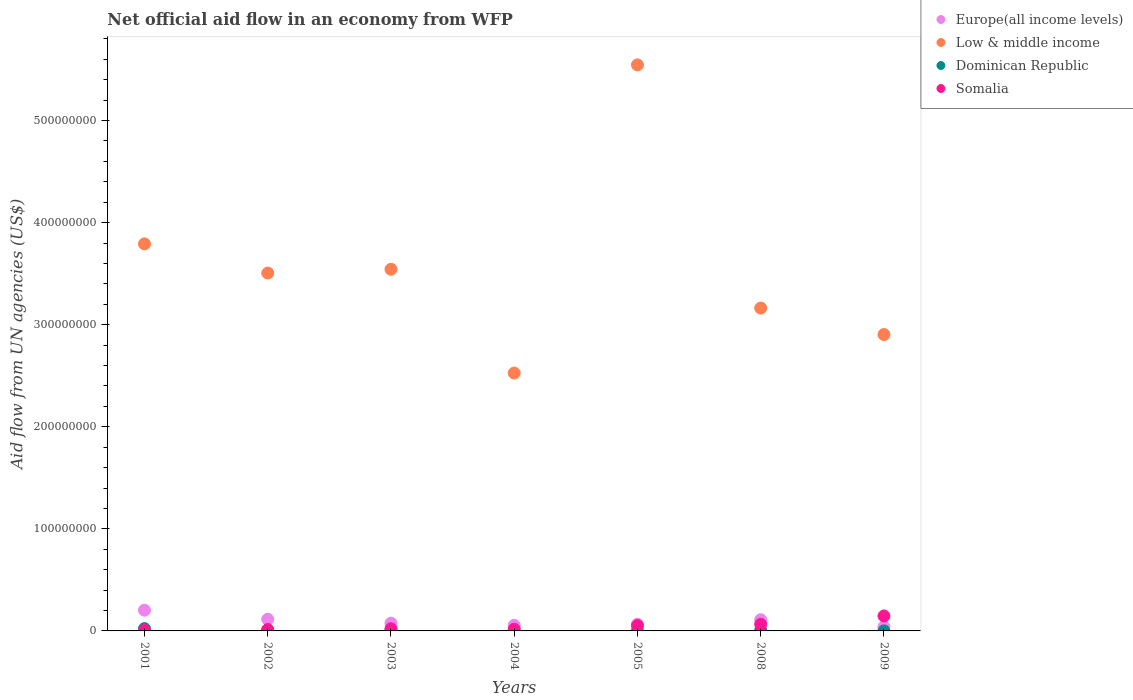How many different coloured dotlines are there?
Make the answer very short. 4. Is the number of dotlines equal to the number of legend labels?
Provide a succinct answer. Yes. What is the net official aid flow in Dominican Republic in 2009?
Provide a short and direct response. 3.00e+04. Across all years, what is the maximum net official aid flow in Low & middle income?
Provide a succinct answer. 5.55e+08. Across all years, what is the minimum net official aid flow in Somalia?
Offer a very short reply. 9.90e+05. What is the total net official aid flow in Dominican Republic in the graph?
Give a very brief answer. 3.99e+06. What is the difference between the net official aid flow in Somalia in 2003 and that in 2009?
Offer a very short reply. -1.25e+07. What is the difference between the net official aid flow in Europe(all income levels) in 2004 and the net official aid flow in Somalia in 2009?
Keep it short and to the point. -9.22e+06. What is the average net official aid flow in Low & middle income per year?
Your response must be concise. 3.57e+08. In the year 2005, what is the difference between the net official aid flow in Dominican Republic and net official aid flow in Europe(all income levels)?
Your response must be concise. -6.54e+06. What is the ratio of the net official aid flow in Dominican Republic in 2001 to that in 2003?
Make the answer very short. 5.14. Is the net official aid flow in Low & middle income in 2001 less than that in 2004?
Ensure brevity in your answer.  No. Is the difference between the net official aid flow in Dominican Republic in 2003 and 2005 greater than the difference between the net official aid flow in Europe(all income levels) in 2003 and 2005?
Your answer should be very brief. No. What is the difference between the highest and the second highest net official aid flow in Somalia?
Offer a terse response. 8.11e+06. What is the difference between the highest and the lowest net official aid flow in Europe(all income levels)?
Offer a terse response. 1.62e+07. Is the sum of the net official aid flow in Dominican Republic in 2001 and 2005 greater than the maximum net official aid flow in Low & middle income across all years?
Keep it short and to the point. No. Is it the case that in every year, the sum of the net official aid flow in Europe(all income levels) and net official aid flow in Dominican Republic  is greater than the net official aid flow in Low & middle income?
Provide a succinct answer. No. Does the net official aid flow in Dominican Republic monotonically increase over the years?
Make the answer very short. No. Is the net official aid flow in Europe(all income levels) strictly less than the net official aid flow in Low & middle income over the years?
Provide a short and direct response. Yes. How many years are there in the graph?
Make the answer very short. 7. What is the difference between two consecutive major ticks on the Y-axis?
Your answer should be very brief. 1.00e+08. Does the graph contain any zero values?
Give a very brief answer. No. Does the graph contain grids?
Offer a terse response. No. How are the legend labels stacked?
Keep it short and to the point. Vertical. What is the title of the graph?
Offer a very short reply. Net official aid flow in an economy from WFP. What is the label or title of the X-axis?
Keep it short and to the point. Years. What is the label or title of the Y-axis?
Keep it short and to the point. Aid flow from UN agencies (US$). What is the Aid flow from UN agencies (US$) in Europe(all income levels) in 2001?
Ensure brevity in your answer.  2.03e+07. What is the Aid flow from UN agencies (US$) in Low & middle income in 2001?
Offer a terse response. 3.79e+08. What is the Aid flow from UN agencies (US$) of Dominican Republic in 2001?
Provide a succinct answer. 2.26e+06. What is the Aid flow from UN agencies (US$) of Somalia in 2001?
Keep it short and to the point. 9.90e+05. What is the Aid flow from UN agencies (US$) of Europe(all income levels) in 2002?
Ensure brevity in your answer.  1.14e+07. What is the Aid flow from UN agencies (US$) of Low & middle income in 2002?
Keep it short and to the point. 3.51e+08. What is the Aid flow from UN agencies (US$) in Somalia in 2002?
Provide a succinct answer. 1.39e+06. What is the Aid flow from UN agencies (US$) in Europe(all income levels) in 2003?
Your answer should be very brief. 7.55e+06. What is the Aid flow from UN agencies (US$) of Low & middle income in 2003?
Your answer should be compact. 3.54e+08. What is the Aid flow from UN agencies (US$) in Dominican Republic in 2003?
Ensure brevity in your answer.  4.40e+05. What is the Aid flow from UN agencies (US$) in Somalia in 2003?
Your answer should be very brief. 2.11e+06. What is the Aid flow from UN agencies (US$) of Europe(all income levels) in 2004?
Offer a terse response. 5.42e+06. What is the Aid flow from UN agencies (US$) of Low & middle income in 2004?
Your answer should be very brief. 2.53e+08. What is the Aid flow from UN agencies (US$) of Dominican Republic in 2004?
Your response must be concise. 1.70e+05. What is the Aid flow from UN agencies (US$) of Somalia in 2004?
Offer a terse response. 1.65e+06. What is the Aid flow from UN agencies (US$) of Europe(all income levels) in 2005?
Ensure brevity in your answer.  6.56e+06. What is the Aid flow from UN agencies (US$) of Low & middle income in 2005?
Offer a terse response. 5.55e+08. What is the Aid flow from UN agencies (US$) in Somalia in 2005?
Keep it short and to the point. 5.21e+06. What is the Aid flow from UN agencies (US$) in Europe(all income levels) in 2008?
Your response must be concise. 1.10e+07. What is the Aid flow from UN agencies (US$) of Low & middle income in 2008?
Offer a terse response. 3.16e+08. What is the Aid flow from UN agencies (US$) of Dominican Republic in 2008?
Offer a terse response. 6.90e+05. What is the Aid flow from UN agencies (US$) of Somalia in 2008?
Make the answer very short. 6.53e+06. What is the Aid flow from UN agencies (US$) in Europe(all income levels) in 2009?
Provide a short and direct response. 4.05e+06. What is the Aid flow from UN agencies (US$) in Low & middle income in 2009?
Give a very brief answer. 2.90e+08. What is the Aid flow from UN agencies (US$) in Somalia in 2009?
Your answer should be very brief. 1.46e+07. Across all years, what is the maximum Aid flow from UN agencies (US$) in Europe(all income levels)?
Your answer should be very brief. 2.03e+07. Across all years, what is the maximum Aid flow from UN agencies (US$) in Low & middle income?
Offer a very short reply. 5.55e+08. Across all years, what is the maximum Aid flow from UN agencies (US$) of Dominican Republic?
Offer a very short reply. 2.26e+06. Across all years, what is the maximum Aid flow from UN agencies (US$) in Somalia?
Provide a succinct answer. 1.46e+07. Across all years, what is the minimum Aid flow from UN agencies (US$) of Europe(all income levels)?
Offer a very short reply. 4.05e+06. Across all years, what is the minimum Aid flow from UN agencies (US$) in Low & middle income?
Make the answer very short. 2.53e+08. Across all years, what is the minimum Aid flow from UN agencies (US$) of Somalia?
Your answer should be compact. 9.90e+05. What is the total Aid flow from UN agencies (US$) of Europe(all income levels) in the graph?
Offer a very short reply. 6.62e+07. What is the total Aid flow from UN agencies (US$) of Low & middle income in the graph?
Make the answer very short. 2.50e+09. What is the total Aid flow from UN agencies (US$) of Dominican Republic in the graph?
Make the answer very short. 3.99e+06. What is the total Aid flow from UN agencies (US$) in Somalia in the graph?
Ensure brevity in your answer.  3.25e+07. What is the difference between the Aid flow from UN agencies (US$) in Europe(all income levels) in 2001 and that in 2002?
Offer a very short reply. 8.89e+06. What is the difference between the Aid flow from UN agencies (US$) of Low & middle income in 2001 and that in 2002?
Ensure brevity in your answer.  2.86e+07. What is the difference between the Aid flow from UN agencies (US$) of Dominican Republic in 2001 and that in 2002?
Ensure brevity in your answer.  1.88e+06. What is the difference between the Aid flow from UN agencies (US$) in Somalia in 2001 and that in 2002?
Your answer should be compact. -4.00e+05. What is the difference between the Aid flow from UN agencies (US$) in Europe(all income levels) in 2001 and that in 2003?
Give a very brief answer. 1.27e+07. What is the difference between the Aid flow from UN agencies (US$) of Low & middle income in 2001 and that in 2003?
Your response must be concise. 2.49e+07. What is the difference between the Aid flow from UN agencies (US$) of Dominican Republic in 2001 and that in 2003?
Keep it short and to the point. 1.82e+06. What is the difference between the Aid flow from UN agencies (US$) in Somalia in 2001 and that in 2003?
Provide a succinct answer. -1.12e+06. What is the difference between the Aid flow from UN agencies (US$) of Europe(all income levels) in 2001 and that in 2004?
Your answer should be compact. 1.49e+07. What is the difference between the Aid flow from UN agencies (US$) of Low & middle income in 2001 and that in 2004?
Ensure brevity in your answer.  1.27e+08. What is the difference between the Aid flow from UN agencies (US$) of Dominican Republic in 2001 and that in 2004?
Offer a very short reply. 2.09e+06. What is the difference between the Aid flow from UN agencies (US$) in Somalia in 2001 and that in 2004?
Offer a terse response. -6.60e+05. What is the difference between the Aid flow from UN agencies (US$) of Europe(all income levels) in 2001 and that in 2005?
Provide a short and direct response. 1.37e+07. What is the difference between the Aid flow from UN agencies (US$) in Low & middle income in 2001 and that in 2005?
Offer a terse response. -1.75e+08. What is the difference between the Aid flow from UN agencies (US$) of Dominican Republic in 2001 and that in 2005?
Make the answer very short. 2.24e+06. What is the difference between the Aid flow from UN agencies (US$) of Somalia in 2001 and that in 2005?
Your response must be concise. -4.22e+06. What is the difference between the Aid flow from UN agencies (US$) in Europe(all income levels) in 2001 and that in 2008?
Your answer should be very brief. 9.30e+06. What is the difference between the Aid flow from UN agencies (US$) in Low & middle income in 2001 and that in 2008?
Your answer should be very brief. 6.29e+07. What is the difference between the Aid flow from UN agencies (US$) of Dominican Republic in 2001 and that in 2008?
Make the answer very short. 1.57e+06. What is the difference between the Aid flow from UN agencies (US$) in Somalia in 2001 and that in 2008?
Make the answer very short. -5.54e+06. What is the difference between the Aid flow from UN agencies (US$) of Europe(all income levels) in 2001 and that in 2009?
Make the answer very short. 1.62e+07. What is the difference between the Aid flow from UN agencies (US$) in Low & middle income in 2001 and that in 2009?
Provide a succinct answer. 8.88e+07. What is the difference between the Aid flow from UN agencies (US$) of Dominican Republic in 2001 and that in 2009?
Give a very brief answer. 2.23e+06. What is the difference between the Aid flow from UN agencies (US$) of Somalia in 2001 and that in 2009?
Your answer should be compact. -1.36e+07. What is the difference between the Aid flow from UN agencies (US$) in Europe(all income levels) in 2002 and that in 2003?
Your answer should be compact. 3.84e+06. What is the difference between the Aid flow from UN agencies (US$) of Low & middle income in 2002 and that in 2003?
Your answer should be compact. -3.67e+06. What is the difference between the Aid flow from UN agencies (US$) of Somalia in 2002 and that in 2003?
Ensure brevity in your answer.  -7.20e+05. What is the difference between the Aid flow from UN agencies (US$) of Europe(all income levels) in 2002 and that in 2004?
Provide a succinct answer. 5.97e+06. What is the difference between the Aid flow from UN agencies (US$) in Low & middle income in 2002 and that in 2004?
Offer a very short reply. 9.80e+07. What is the difference between the Aid flow from UN agencies (US$) of Europe(all income levels) in 2002 and that in 2005?
Make the answer very short. 4.83e+06. What is the difference between the Aid flow from UN agencies (US$) in Low & middle income in 2002 and that in 2005?
Provide a short and direct response. -2.04e+08. What is the difference between the Aid flow from UN agencies (US$) in Dominican Republic in 2002 and that in 2005?
Make the answer very short. 3.60e+05. What is the difference between the Aid flow from UN agencies (US$) in Somalia in 2002 and that in 2005?
Provide a succinct answer. -3.82e+06. What is the difference between the Aid flow from UN agencies (US$) of Low & middle income in 2002 and that in 2008?
Offer a very short reply. 3.43e+07. What is the difference between the Aid flow from UN agencies (US$) in Dominican Republic in 2002 and that in 2008?
Ensure brevity in your answer.  -3.10e+05. What is the difference between the Aid flow from UN agencies (US$) of Somalia in 2002 and that in 2008?
Your answer should be compact. -5.14e+06. What is the difference between the Aid flow from UN agencies (US$) of Europe(all income levels) in 2002 and that in 2009?
Your answer should be compact. 7.34e+06. What is the difference between the Aid flow from UN agencies (US$) of Low & middle income in 2002 and that in 2009?
Offer a very short reply. 6.03e+07. What is the difference between the Aid flow from UN agencies (US$) of Dominican Republic in 2002 and that in 2009?
Make the answer very short. 3.50e+05. What is the difference between the Aid flow from UN agencies (US$) of Somalia in 2002 and that in 2009?
Provide a short and direct response. -1.32e+07. What is the difference between the Aid flow from UN agencies (US$) in Europe(all income levels) in 2003 and that in 2004?
Your answer should be very brief. 2.13e+06. What is the difference between the Aid flow from UN agencies (US$) in Low & middle income in 2003 and that in 2004?
Keep it short and to the point. 1.02e+08. What is the difference between the Aid flow from UN agencies (US$) of Dominican Republic in 2003 and that in 2004?
Keep it short and to the point. 2.70e+05. What is the difference between the Aid flow from UN agencies (US$) in Somalia in 2003 and that in 2004?
Offer a very short reply. 4.60e+05. What is the difference between the Aid flow from UN agencies (US$) of Europe(all income levels) in 2003 and that in 2005?
Offer a very short reply. 9.90e+05. What is the difference between the Aid flow from UN agencies (US$) in Low & middle income in 2003 and that in 2005?
Your answer should be very brief. -2.00e+08. What is the difference between the Aid flow from UN agencies (US$) in Dominican Republic in 2003 and that in 2005?
Offer a terse response. 4.20e+05. What is the difference between the Aid flow from UN agencies (US$) in Somalia in 2003 and that in 2005?
Your answer should be very brief. -3.10e+06. What is the difference between the Aid flow from UN agencies (US$) in Europe(all income levels) in 2003 and that in 2008?
Offer a very short reply. -3.43e+06. What is the difference between the Aid flow from UN agencies (US$) of Low & middle income in 2003 and that in 2008?
Offer a terse response. 3.80e+07. What is the difference between the Aid flow from UN agencies (US$) of Somalia in 2003 and that in 2008?
Offer a very short reply. -4.42e+06. What is the difference between the Aid flow from UN agencies (US$) of Europe(all income levels) in 2003 and that in 2009?
Give a very brief answer. 3.50e+06. What is the difference between the Aid flow from UN agencies (US$) of Low & middle income in 2003 and that in 2009?
Offer a terse response. 6.39e+07. What is the difference between the Aid flow from UN agencies (US$) in Somalia in 2003 and that in 2009?
Your answer should be very brief. -1.25e+07. What is the difference between the Aid flow from UN agencies (US$) of Europe(all income levels) in 2004 and that in 2005?
Provide a short and direct response. -1.14e+06. What is the difference between the Aid flow from UN agencies (US$) of Low & middle income in 2004 and that in 2005?
Provide a succinct answer. -3.02e+08. What is the difference between the Aid flow from UN agencies (US$) in Somalia in 2004 and that in 2005?
Ensure brevity in your answer.  -3.56e+06. What is the difference between the Aid flow from UN agencies (US$) in Europe(all income levels) in 2004 and that in 2008?
Your response must be concise. -5.56e+06. What is the difference between the Aid flow from UN agencies (US$) of Low & middle income in 2004 and that in 2008?
Offer a terse response. -6.37e+07. What is the difference between the Aid flow from UN agencies (US$) of Dominican Republic in 2004 and that in 2008?
Ensure brevity in your answer.  -5.20e+05. What is the difference between the Aid flow from UN agencies (US$) in Somalia in 2004 and that in 2008?
Your answer should be very brief. -4.88e+06. What is the difference between the Aid flow from UN agencies (US$) of Europe(all income levels) in 2004 and that in 2009?
Your answer should be compact. 1.37e+06. What is the difference between the Aid flow from UN agencies (US$) in Low & middle income in 2004 and that in 2009?
Your response must be concise. -3.77e+07. What is the difference between the Aid flow from UN agencies (US$) of Dominican Republic in 2004 and that in 2009?
Give a very brief answer. 1.40e+05. What is the difference between the Aid flow from UN agencies (US$) in Somalia in 2004 and that in 2009?
Your answer should be compact. -1.30e+07. What is the difference between the Aid flow from UN agencies (US$) in Europe(all income levels) in 2005 and that in 2008?
Provide a short and direct response. -4.42e+06. What is the difference between the Aid flow from UN agencies (US$) in Low & middle income in 2005 and that in 2008?
Your response must be concise. 2.38e+08. What is the difference between the Aid flow from UN agencies (US$) in Dominican Republic in 2005 and that in 2008?
Make the answer very short. -6.70e+05. What is the difference between the Aid flow from UN agencies (US$) of Somalia in 2005 and that in 2008?
Keep it short and to the point. -1.32e+06. What is the difference between the Aid flow from UN agencies (US$) of Europe(all income levels) in 2005 and that in 2009?
Your answer should be very brief. 2.51e+06. What is the difference between the Aid flow from UN agencies (US$) in Low & middle income in 2005 and that in 2009?
Give a very brief answer. 2.64e+08. What is the difference between the Aid flow from UN agencies (US$) of Somalia in 2005 and that in 2009?
Give a very brief answer. -9.43e+06. What is the difference between the Aid flow from UN agencies (US$) of Europe(all income levels) in 2008 and that in 2009?
Provide a short and direct response. 6.93e+06. What is the difference between the Aid flow from UN agencies (US$) of Low & middle income in 2008 and that in 2009?
Make the answer very short. 2.59e+07. What is the difference between the Aid flow from UN agencies (US$) in Dominican Republic in 2008 and that in 2009?
Offer a very short reply. 6.60e+05. What is the difference between the Aid flow from UN agencies (US$) of Somalia in 2008 and that in 2009?
Ensure brevity in your answer.  -8.11e+06. What is the difference between the Aid flow from UN agencies (US$) of Europe(all income levels) in 2001 and the Aid flow from UN agencies (US$) of Low & middle income in 2002?
Offer a terse response. -3.30e+08. What is the difference between the Aid flow from UN agencies (US$) in Europe(all income levels) in 2001 and the Aid flow from UN agencies (US$) in Dominican Republic in 2002?
Give a very brief answer. 1.99e+07. What is the difference between the Aid flow from UN agencies (US$) in Europe(all income levels) in 2001 and the Aid flow from UN agencies (US$) in Somalia in 2002?
Offer a very short reply. 1.89e+07. What is the difference between the Aid flow from UN agencies (US$) in Low & middle income in 2001 and the Aid flow from UN agencies (US$) in Dominican Republic in 2002?
Keep it short and to the point. 3.79e+08. What is the difference between the Aid flow from UN agencies (US$) in Low & middle income in 2001 and the Aid flow from UN agencies (US$) in Somalia in 2002?
Provide a succinct answer. 3.78e+08. What is the difference between the Aid flow from UN agencies (US$) in Dominican Republic in 2001 and the Aid flow from UN agencies (US$) in Somalia in 2002?
Your response must be concise. 8.70e+05. What is the difference between the Aid flow from UN agencies (US$) of Europe(all income levels) in 2001 and the Aid flow from UN agencies (US$) of Low & middle income in 2003?
Keep it short and to the point. -3.34e+08. What is the difference between the Aid flow from UN agencies (US$) of Europe(all income levels) in 2001 and the Aid flow from UN agencies (US$) of Dominican Republic in 2003?
Provide a succinct answer. 1.98e+07. What is the difference between the Aid flow from UN agencies (US$) of Europe(all income levels) in 2001 and the Aid flow from UN agencies (US$) of Somalia in 2003?
Provide a succinct answer. 1.82e+07. What is the difference between the Aid flow from UN agencies (US$) in Low & middle income in 2001 and the Aid flow from UN agencies (US$) in Dominican Republic in 2003?
Provide a short and direct response. 3.79e+08. What is the difference between the Aid flow from UN agencies (US$) of Low & middle income in 2001 and the Aid flow from UN agencies (US$) of Somalia in 2003?
Provide a succinct answer. 3.77e+08. What is the difference between the Aid flow from UN agencies (US$) of Europe(all income levels) in 2001 and the Aid flow from UN agencies (US$) of Low & middle income in 2004?
Your response must be concise. -2.32e+08. What is the difference between the Aid flow from UN agencies (US$) of Europe(all income levels) in 2001 and the Aid flow from UN agencies (US$) of Dominican Republic in 2004?
Provide a short and direct response. 2.01e+07. What is the difference between the Aid flow from UN agencies (US$) of Europe(all income levels) in 2001 and the Aid flow from UN agencies (US$) of Somalia in 2004?
Your response must be concise. 1.86e+07. What is the difference between the Aid flow from UN agencies (US$) in Low & middle income in 2001 and the Aid flow from UN agencies (US$) in Dominican Republic in 2004?
Make the answer very short. 3.79e+08. What is the difference between the Aid flow from UN agencies (US$) in Low & middle income in 2001 and the Aid flow from UN agencies (US$) in Somalia in 2004?
Keep it short and to the point. 3.78e+08. What is the difference between the Aid flow from UN agencies (US$) in Dominican Republic in 2001 and the Aid flow from UN agencies (US$) in Somalia in 2004?
Make the answer very short. 6.10e+05. What is the difference between the Aid flow from UN agencies (US$) in Europe(all income levels) in 2001 and the Aid flow from UN agencies (US$) in Low & middle income in 2005?
Offer a very short reply. -5.34e+08. What is the difference between the Aid flow from UN agencies (US$) of Europe(all income levels) in 2001 and the Aid flow from UN agencies (US$) of Dominican Republic in 2005?
Provide a succinct answer. 2.03e+07. What is the difference between the Aid flow from UN agencies (US$) in Europe(all income levels) in 2001 and the Aid flow from UN agencies (US$) in Somalia in 2005?
Provide a short and direct response. 1.51e+07. What is the difference between the Aid flow from UN agencies (US$) of Low & middle income in 2001 and the Aid flow from UN agencies (US$) of Dominican Republic in 2005?
Your response must be concise. 3.79e+08. What is the difference between the Aid flow from UN agencies (US$) of Low & middle income in 2001 and the Aid flow from UN agencies (US$) of Somalia in 2005?
Ensure brevity in your answer.  3.74e+08. What is the difference between the Aid flow from UN agencies (US$) of Dominican Republic in 2001 and the Aid flow from UN agencies (US$) of Somalia in 2005?
Your answer should be compact. -2.95e+06. What is the difference between the Aid flow from UN agencies (US$) of Europe(all income levels) in 2001 and the Aid flow from UN agencies (US$) of Low & middle income in 2008?
Your response must be concise. -2.96e+08. What is the difference between the Aid flow from UN agencies (US$) of Europe(all income levels) in 2001 and the Aid flow from UN agencies (US$) of Dominican Republic in 2008?
Make the answer very short. 1.96e+07. What is the difference between the Aid flow from UN agencies (US$) in Europe(all income levels) in 2001 and the Aid flow from UN agencies (US$) in Somalia in 2008?
Make the answer very short. 1.38e+07. What is the difference between the Aid flow from UN agencies (US$) in Low & middle income in 2001 and the Aid flow from UN agencies (US$) in Dominican Republic in 2008?
Ensure brevity in your answer.  3.78e+08. What is the difference between the Aid flow from UN agencies (US$) in Low & middle income in 2001 and the Aid flow from UN agencies (US$) in Somalia in 2008?
Your answer should be compact. 3.73e+08. What is the difference between the Aid flow from UN agencies (US$) in Dominican Republic in 2001 and the Aid flow from UN agencies (US$) in Somalia in 2008?
Offer a terse response. -4.27e+06. What is the difference between the Aid flow from UN agencies (US$) of Europe(all income levels) in 2001 and the Aid flow from UN agencies (US$) of Low & middle income in 2009?
Provide a succinct answer. -2.70e+08. What is the difference between the Aid flow from UN agencies (US$) of Europe(all income levels) in 2001 and the Aid flow from UN agencies (US$) of Dominican Republic in 2009?
Offer a terse response. 2.02e+07. What is the difference between the Aid flow from UN agencies (US$) of Europe(all income levels) in 2001 and the Aid flow from UN agencies (US$) of Somalia in 2009?
Keep it short and to the point. 5.64e+06. What is the difference between the Aid flow from UN agencies (US$) of Low & middle income in 2001 and the Aid flow from UN agencies (US$) of Dominican Republic in 2009?
Provide a succinct answer. 3.79e+08. What is the difference between the Aid flow from UN agencies (US$) of Low & middle income in 2001 and the Aid flow from UN agencies (US$) of Somalia in 2009?
Offer a terse response. 3.65e+08. What is the difference between the Aid flow from UN agencies (US$) of Dominican Republic in 2001 and the Aid flow from UN agencies (US$) of Somalia in 2009?
Your response must be concise. -1.24e+07. What is the difference between the Aid flow from UN agencies (US$) in Europe(all income levels) in 2002 and the Aid flow from UN agencies (US$) in Low & middle income in 2003?
Offer a terse response. -3.43e+08. What is the difference between the Aid flow from UN agencies (US$) in Europe(all income levels) in 2002 and the Aid flow from UN agencies (US$) in Dominican Republic in 2003?
Your answer should be very brief. 1.10e+07. What is the difference between the Aid flow from UN agencies (US$) in Europe(all income levels) in 2002 and the Aid flow from UN agencies (US$) in Somalia in 2003?
Give a very brief answer. 9.28e+06. What is the difference between the Aid flow from UN agencies (US$) of Low & middle income in 2002 and the Aid flow from UN agencies (US$) of Dominican Republic in 2003?
Provide a short and direct response. 3.50e+08. What is the difference between the Aid flow from UN agencies (US$) in Low & middle income in 2002 and the Aid flow from UN agencies (US$) in Somalia in 2003?
Ensure brevity in your answer.  3.48e+08. What is the difference between the Aid flow from UN agencies (US$) of Dominican Republic in 2002 and the Aid flow from UN agencies (US$) of Somalia in 2003?
Ensure brevity in your answer.  -1.73e+06. What is the difference between the Aid flow from UN agencies (US$) of Europe(all income levels) in 2002 and the Aid flow from UN agencies (US$) of Low & middle income in 2004?
Offer a terse response. -2.41e+08. What is the difference between the Aid flow from UN agencies (US$) of Europe(all income levels) in 2002 and the Aid flow from UN agencies (US$) of Dominican Republic in 2004?
Give a very brief answer. 1.12e+07. What is the difference between the Aid flow from UN agencies (US$) in Europe(all income levels) in 2002 and the Aid flow from UN agencies (US$) in Somalia in 2004?
Your answer should be compact. 9.74e+06. What is the difference between the Aid flow from UN agencies (US$) of Low & middle income in 2002 and the Aid flow from UN agencies (US$) of Dominican Republic in 2004?
Provide a short and direct response. 3.50e+08. What is the difference between the Aid flow from UN agencies (US$) of Low & middle income in 2002 and the Aid flow from UN agencies (US$) of Somalia in 2004?
Make the answer very short. 3.49e+08. What is the difference between the Aid flow from UN agencies (US$) in Dominican Republic in 2002 and the Aid flow from UN agencies (US$) in Somalia in 2004?
Keep it short and to the point. -1.27e+06. What is the difference between the Aid flow from UN agencies (US$) in Europe(all income levels) in 2002 and the Aid flow from UN agencies (US$) in Low & middle income in 2005?
Keep it short and to the point. -5.43e+08. What is the difference between the Aid flow from UN agencies (US$) of Europe(all income levels) in 2002 and the Aid flow from UN agencies (US$) of Dominican Republic in 2005?
Make the answer very short. 1.14e+07. What is the difference between the Aid flow from UN agencies (US$) in Europe(all income levels) in 2002 and the Aid flow from UN agencies (US$) in Somalia in 2005?
Your answer should be very brief. 6.18e+06. What is the difference between the Aid flow from UN agencies (US$) in Low & middle income in 2002 and the Aid flow from UN agencies (US$) in Dominican Republic in 2005?
Your response must be concise. 3.51e+08. What is the difference between the Aid flow from UN agencies (US$) in Low & middle income in 2002 and the Aid flow from UN agencies (US$) in Somalia in 2005?
Offer a very short reply. 3.45e+08. What is the difference between the Aid flow from UN agencies (US$) of Dominican Republic in 2002 and the Aid flow from UN agencies (US$) of Somalia in 2005?
Your answer should be compact. -4.83e+06. What is the difference between the Aid flow from UN agencies (US$) of Europe(all income levels) in 2002 and the Aid flow from UN agencies (US$) of Low & middle income in 2008?
Keep it short and to the point. -3.05e+08. What is the difference between the Aid flow from UN agencies (US$) of Europe(all income levels) in 2002 and the Aid flow from UN agencies (US$) of Dominican Republic in 2008?
Keep it short and to the point. 1.07e+07. What is the difference between the Aid flow from UN agencies (US$) of Europe(all income levels) in 2002 and the Aid flow from UN agencies (US$) of Somalia in 2008?
Offer a very short reply. 4.86e+06. What is the difference between the Aid flow from UN agencies (US$) of Low & middle income in 2002 and the Aid flow from UN agencies (US$) of Dominican Republic in 2008?
Provide a succinct answer. 3.50e+08. What is the difference between the Aid flow from UN agencies (US$) in Low & middle income in 2002 and the Aid flow from UN agencies (US$) in Somalia in 2008?
Provide a short and direct response. 3.44e+08. What is the difference between the Aid flow from UN agencies (US$) of Dominican Republic in 2002 and the Aid flow from UN agencies (US$) of Somalia in 2008?
Your response must be concise. -6.15e+06. What is the difference between the Aid flow from UN agencies (US$) in Europe(all income levels) in 2002 and the Aid flow from UN agencies (US$) in Low & middle income in 2009?
Make the answer very short. -2.79e+08. What is the difference between the Aid flow from UN agencies (US$) of Europe(all income levels) in 2002 and the Aid flow from UN agencies (US$) of Dominican Republic in 2009?
Your response must be concise. 1.14e+07. What is the difference between the Aid flow from UN agencies (US$) in Europe(all income levels) in 2002 and the Aid flow from UN agencies (US$) in Somalia in 2009?
Give a very brief answer. -3.25e+06. What is the difference between the Aid flow from UN agencies (US$) of Low & middle income in 2002 and the Aid flow from UN agencies (US$) of Dominican Republic in 2009?
Ensure brevity in your answer.  3.51e+08. What is the difference between the Aid flow from UN agencies (US$) of Low & middle income in 2002 and the Aid flow from UN agencies (US$) of Somalia in 2009?
Offer a very short reply. 3.36e+08. What is the difference between the Aid flow from UN agencies (US$) in Dominican Republic in 2002 and the Aid flow from UN agencies (US$) in Somalia in 2009?
Provide a succinct answer. -1.43e+07. What is the difference between the Aid flow from UN agencies (US$) in Europe(all income levels) in 2003 and the Aid flow from UN agencies (US$) in Low & middle income in 2004?
Keep it short and to the point. -2.45e+08. What is the difference between the Aid flow from UN agencies (US$) in Europe(all income levels) in 2003 and the Aid flow from UN agencies (US$) in Dominican Republic in 2004?
Ensure brevity in your answer.  7.38e+06. What is the difference between the Aid flow from UN agencies (US$) of Europe(all income levels) in 2003 and the Aid flow from UN agencies (US$) of Somalia in 2004?
Offer a very short reply. 5.90e+06. What is the difference between the Aid flow from UN agencies (US$) of Low & middle income in 2003 and the Aid flow from UN agencies (US$) of Dominican Republic in 2004?
Your answer should be very brief. 3.54e+08. What is the difference between the Aid flow from UN agencies (US$) of Low & middle income in 2003 and the Aid flow from UN agencies (US$) of Somalia in 2004?
Offer a terse response. 3.53e+08. What is the difference between the Aid flow from UN agencies (US$) of Dominican Republic in 2003 and the Aid flow from UN agencies (US$) of Somalia in 2004?
Make the answer very short. -1.21e+06. What is the difference between the Aid flow from UN agencies (US$) in Europe(all income levels) in 2003 and the Aid flow from UN agencies (US$) in Low & middle income in 2005?
Ensure brevity in your answer.  -5.47e+08. What is the difference between the Aid flow from UN agencies (US$) of Europe(all income levels) in 2003 and the Aid flow from UN agencies (US$) of Dominican Republic in 2005?
Your answer should be very brief. 7.53e+06. What is the difference between the Aid flow from UN agencies (US$) in Europe(all income levels) in 2003 and the Aid flow from UN agencies (US$) in Somalia in 2005?
Make the answer very short. 2.34e+06. What is the difference between the Aid flow from UN agencies (US$) in Low & middle income in 2003 and the Aid flow from UN agencies (US$) in Dominican Republic in 2005?
Provide a short and direct response. 3.54e+08. What is the difference between the Aid flow from UN agencies (US$) of Low & middle income in 2003 and the Aid flow from UN agencies (US$) of Somalia in 2005?
Provide a succinct answer. 3.49e+08. What is the difference between the Aid flow from UN agencies (US$) of Dominican Republic in 2003 and the Aid flow from UN agencies (US$) of Somalia in 2005?
Provide a succinct answer. -4.77e+06. What is the difference between the Aid flow from UN agencies (US$) in Europe(all income levels) in 2003 and the Aid flow from UN agencies (US$) in Low & middle income in 2008?
Offer a very short reply. -3.09e+08. What is the difference between the Aid flow from UN agencies (US$) of Europe(all income levels) in 2003 and the Aid flow from UN agencies (US$) of Dominican Republic in 2008?
Offer a very short reply. 6.86e+06. What is the difference between the Aid flow from UN agencies (US$) in Europe(all income levels) in 2003 and the Aid flow from UN agencies (US$) in Somalia in 2008?
Give a very brief answer. 1.02e+06. What is the difference between the Aid flow from UN agencies (US$) of Low & middle income in 2003 and the Aid flow from UN agencies (US$) of Dominican Republic in 2008?
Your answer should be compact. 3.54e+08. What is the difference between the Aid flow from UN agencies (US$) of Low & middle income in 2003 and the Aid flow from UN agencies (US$) of Somalia in 2008?
Ensure brevity in your answer.  3.48e+08. What is the difference between the Aid flow from UN agencies (US$) in Dominican Republic in 2003 and the Aid flow from UN agencies (US$) in Somalia in 2008?
Ensure brevity in your answer.  -6.09e+06. What is the difference between the Aid flow from UN agencies (US$) in Europe(all income levels) in 2003 and the Aid flow from UN agencies (US$) in Low & middle income in 2009?
Ensure brevity in your answer.  -2.83e+08. What is the difference between the Aid flow from UN agencies (US$) of Europe(all income levels) in 2003 and the Aid flow from UN agencies (US$) of Dominican Republic in 2009?
Offer a very short reply. 7.52e+06. What is the difference between the Aid flow from UN agencies (US$) of Europe(all income levels) in 2003 and the Aid flow from UN agencies (US$) of Somalia in 2009?
Provide a succinct answer. -7.09e+06. What is the difference between the Aid flow from UN agencies (US$) of Low & middle income in 2003 and the Aid flow from UN agencies (US$) of Dominican Republic in 2009?
Your answer should be compact. 3.54e+08. What is the difference between the Aid flow from UN agencies (US$) of Low & middle income in 2003 and the Aid flow from UN agencies (US$) of Somalia in 2009?
Give a very brief answer. 3.40e+08. What is the difference between the Aid flow from UN agencies (US$) of Dominican Republic in 2003 and the Aid flow from UN agencies (US$) of Somalia in 2009?
Keep it short and to the point. -1.42e+07. What is the difference between the Aid flow from UN agencies (US$) in Europe(all income levels) in 2004 and the Aid flow from UN agencies (US$) in Low & middle income in 2005?
Offer a very short reply. -5.49e+08. What is the difference between the Aid flow from UN agencies (US$) of Europe(all income levels) in 2004 and the Aid flow from UN agencies (US$) of Dominican Republic in 2005?
Your answer should be very brief. 5.40e+06. What is the difference between the Aid flow from UN agencies (US$) in Europe(all income levels) in 2004 and the Aid flow from UN agencies (US$) in Somalia in 2005?
Provide a short and direct response. 2.10e+05. What is the difference between the Aid flow from UN agencies (US$) of Low & middle income in 2004 and the Aid flow from UN agencies (US$) of Dominican Republic in 2005?
Make the answer very short. 2.53e+08. What is the difference between the Aid flow from UN agencies (US$) in Low & middle income in 2004 and the Aid flow from UN agencies (US$) in Somalia in 2005?
Make the answer very short. 2.47e+08. What is the difference between the Aid flow from UN agencies (US$) of Dominican Republic in 2004 and the Aid flow from UN agencies (US$) of Somalia in 2005?
Offer a terse response. -5.04e+06. What is the difference between the Aid flow from UN agencies (US$) in Europe(all income levels) in 2004 and the Aid flow from UN agencies (US$) in Low & middle income in 2008?
Keep it short and to the point. -3.11e+08. What is the difference between the Aid flow from UN agencies (US$) of Europe(all income levels) in 2004 and the Aid flow from UN agencies (US$) of Dominican Republic in 2008?
Provide a succinct answer. 4.73e+06. What is the difference between the Aid flow from UN agencies (US$) of Europe(all income levels) in 2004 and the Aid flow from UN agencies (US$) of Somalia in 2008?
Your answer should be very brief. -1.11e+06. What is the difference between the Aid flow from UN agencies (US$) of Low & middle income in 2004 and the Aid flow from UN agencies (US$) of Dominican Republic in 2008?
Your answer should be compact. 2.52e+08. What is the difference between the Aid flow from UN agencies (US$) in Low & middle income in 2004 and the Aid flow from UN agencies (US$) in Somalia in 2008?
Keep it short and to the point. 2.46e+08. What is the difference between the Aid flow from UN agencies (US$) in Dominican Republic in 2004 and the Aid flow from UN agencies (US$) in Somalia in 2008?
Give a very brief answer. -6.36e+06. What is the difference between the Aid flow from UN agencies (US$) in Europe(all income levels) in 2004 and the Aid flow from UN agencies (US$) in Low & middle income in 2009?
Your response must be concise. -2.85e+08. What is the difference between the Aid flow from UN agencies (US$) of Europe(all income levels) in 2004 and the Aid flow from UN agencies (US$) of Dominican Republic in 2009?
Offer a very short reply. 5.39e+06. What is the difference between the Aid flow from UN agencies (US$) of Europe(all income levels) in 2004 and the Aid flow from UN agencies (US$) of Somalia in 2009?
Provide a succinct answer. -9.22e+06. What is the difference between the Aid flow from UN agencies (US$) in Low & middle income in 2004 and the Aid flow from UN agencies (US$) in Dominican Republic in 2009?
Offer a very short reply. 2.53e+08. What is the difference between the Aid flow from UN agencies (US$) of Low & middle income in 2004 and the Aid flow from UN agencies (US$) of Somalia in 2009?
Your answer should be compact. 2.38e+08. What is the difference between the Aid flow from UN agencies (US$) in Dominican Republic in 2004 and the Aid flow from UN agencies (US$) in Somalia in 2009?
Offer a very short reply. -1.45e+07. What is the difference between the Aid flow from UN agencies (US$) in Europe(all income levels) in 2005 and the Aid flow from UN agencies (US$) in Low & middle income in 2008?
Offer a very short reply. -3.10e+08. What is the difference between the Aid flow from UN agencies (US$) of Europe(all income levels) in 2005 and the Aid flow from UN agencies (US$) of Dominican Republic in 2008?
Your answer should be very brief. 5.87e+06. What is the difference between the Aid flow from UN agencies (US$) in Europe(all income levels) in 2005 and the Aid flow from UN agencies (US$) in Somalia in 2008?
Offer a terse response. 3.00e+04. What is the difference between the Aid flow from UN agencies (US$) of Low & middle income in 2005 and the Aid flow from UN agencies (US$) of Dominican Republic in 2008?
Provide a succinct answer. 5.54e+08. What is the difference between the Aid flow from UN agencies (US$) of Low & middle income in 2005 and the Aid flow from UN agencies (US$) of Somalia in 2008?
Offer a terse response. 5.48e+08. What is the difference between the Aid flow from UN agencies (US$) in Dominican Republic in 2005 and the Aid flow from UN agencies (US$) in Somalia in 2008?
Offer a very short reply. -6.51e+06. What is the difference between the Aid flow from UN agencies (US$) of Europe(all income levels) in 2005 and the Aid flow from UN agencies (US$) of Low & middle income in 2009?
Make the answer very short. -2.84e+08. What is the difference between the Aid flow from UN agencies (US$) of Europe(all income levels) in 2005 and the Aid flow from UN agencies (US$) of Dominican Republic in 2009?
Keep it short and to the point. 6.53e+06. What is the difference between the Aid flow from UN agencies (US$) in Europe(all income levels) in 2005 and the Aid flow from UN agencies (US$) in Somalia in 2009?
Give a very brief answer. -8.08e+06. What is the difference between the Aid flow from UN agencies (US$) in Low & middle income in 2005 and the Aid flow from UN agencies (US$) in Dominican Republic in 2009?
Your answer should be very brief. 5.54e+08. What is the difference between the Aid flow from UN agencies (US$) of Low & middle income in 2005 and the Aid flow from UN agencies (US$) of Somalia in 2009?
Ensure brevity in your answer.  5.40e+08. What is the difference between the Aid flow from UN agencies (US$) of Dominican Republic in 2005 and the Aid flow from UN agencies (US$) of Somalia in 2009?
Your answer should be compact. -1.46e+07. What is the difference between the Aid flow from UN agencies (US$) of Europe(all income levels) in 2008 and the Aid flow from UN agencies (US$) of Low & middle income in 2009?
Give a very brief answer. -2.79e+08. What is the difference between the Aid flow from UN agencies (US$) in Europe(all income levels) in 2008 and the Aid flow from UN agencies (US$) in Dominican Republic in 2009?
Offer a terse response. 1.10e+07. What is the difference between the Aid flow from UN agencies (US$) of Europe(all income levels) in 2008 and the Aid flow from UN agencies (US$) of Somalia in 2009?
Your response must be concise. -3.66e+06. What is the difference between the Aid flow from UN agencies (US$) of Low & middle income in 2008 and the Aid flow from UN agencies (US$) of Dominican Republic in 2009?
Keep it short and to the point. 3.16e+08. What is the difference between the Aid flow from UN agencies (US$) in Low & middle income in 2008 and the Aid flow from UN agencies (US$) in Somalia in 2009?
Offer a very short reply. 3.02e+08. What is the difference between the Aid flow from UN agencies (US$) in Dominican Republic in 2008 and the Aid flow from UN agencies (US$) in Somalia in 2009?
Your answer should be compact. -1.40e+07. What is the average Aid flow from UN agencies (US$) of Europe(all income levels) per year?
Your answer should be very brief. 9.46e+06. What is the average Aid flow from UN agencies (US$) in Low & middle income per year?
Give a very brief answer. 3.57e+08. What is the average Aid flow from UN agencies (US$) in Dominican Republic per year?
Give a very brief answer. 5.70e+05. What is the average Aid flow from UN agencies (US$) of Somalia per year?
Make the answer very short. 4.65e+06. In the year 2001, what is the difference between the Aid flow from UN agencies (US$) of Europe(all income levels) and Aid flow from UN agencies (US$) of Low & middle income?
Provide a succinct answer. -3.59e+08. In the year 2001, what is the difference between the Aid flow from UN agencies (US$) of Europe(all income levels) and Aid flow from UN agencies (US$) of Dominican Republic?
Make the answer very short. 1.80e+07. In the year 2001, what is the difference between the Aid flow from UN agencies (US$) of Europe(all income levels) and Aid flow from UN agencies (US$) of Somalia?
Offer a terse response. 1.93e+07. In the year 2001, what is the difference between the Aid flow from UN agencies (US$) in Low & middle income and Aid flow from UN agencies (US$) in Dominican Republic?
Your answer should be very brief. 3.77e+08. In the year 2001, what is the difference between the Aid flow from UN agencies (US$) of Low & middle income and Aid flow from UN agencies (US$) of Somalia?
Keep it short and to the point. 3.78e+08. In the year 2001, what is the difference between the Aid flow from UN agencies (US$) in Dominican Republic and Aid flow from UN agencies (US$) in Somalia?
Make the answer very short. 1.27e+06. In the year 2002, what is the difference between the Aid flow from UN agencies (US$) in Europe(all income levels) and Aid flow from UN agencies (US$) in Low & middle income?
Your response must be concise. -3.39e+08. In the year 2002, what is the difference between the Aid flow from UN agencies (US$) of Europe(all income levels) and Aid flow from UN agencies (US$) of Dominican Republic?
Keep it short and to the point. 1.10e+07. In the year 2002, what is the difference between the Aid flow from UN agencies (US$) of Low & middle income and Aid flow from UN agencies (US$) of Dominican Republic?
Keep it short and to the point. 3.50e+08. In the year 2002, what is the difference between the Aid flow from UN agencies (US$) of Low & middle income and Aid flow from UN agencies (US$) of Somalia?
Ensure brevity in your answer.  3.49e+08. In the year 2002, what is the difference between the Aid flow from UN agencies (US$) in Dominican Republic and Aid flow from UN agencies (US$) in Somalia?
Your response must be concise. -1.01e+06. In the year 2003, what is the difference between the Aid flow from UN agencies (US$) in Europe(all income levels) and Aid flow from UN agencies (US$) in Low & middle income?
Offer a very short reply. -3.47e+08. In the year 2003, what is the difference between the Aid flow from UN agencies (US$) of Europe(all income levels) and Aid flow from UN agencies (US$) of Dominican Republic?
Ensure brevity in your answer.  7.11e+06. In the year 2003, what is the difference between the Aid flow from UN agencies (US$) in Europe(all income levels) and Aid flow from UN agencies (US$) in Somalia?
Your answer should be very brief. 5.44e+06. In the year 2003, what is the difference between the Aid flow from UN agencies (US$) in Low & middle income and Aid flow from UN agencies (US$) in Dominican Republic?
Offer a very short reply. 3.54e+08. In the year 2003, what is the difference between the Aid flow from UN agencies (US$) in Low & middle income and Aid flow from UN agencies (US$) in Somalia?
Provide a short and direct response. 3.52e+08. In the year 2003, what is the difference between the Aid flow from UN agencies (US$) in Dominican Republic and Aid flow from UN agencies (US$) in Somalia?
Give a very brief answer. -1.67e+06. In the year 2004, what is the difference between the Aid flow from UN agencies (US$) of Europe(all income levels) and Aid flow from UN agencies (US$) of Low & middle income?
Your answer should be compact. -2.47e+08. In the year 2004, what is the difference between the Aid flow from UN agencies (US$) in Europe(all income levels) and Aid flow from UN agencies (US$) in Dominican Republic?
Provide a succinct answer. 5.25e+06. In the year 2004, what is the difference between the Aid flow from UN agencies (US$) in Europe(all income levels) and Aid flow from UN agencies (US$) in Somalia?
Provide a short and direct response. 3.77e+06. In the year 2004, what is the difference between the Aid flow from UN agencies (US$) of Low & middle income and Aid flow from UN agencies (US$) of Dominican Republic?
Provide a succinct answer. 2.52e+08. In the year 2004, what is the difference between the Aid flow from UN agencies (US$) of Low & middle income and Aid flow from UN agencies (US$) of Somalia?
Your response must be concise. 2.51e+08. In the year 2004, what is the difference between the Aid flow from UN agencies (US$) in Dominican Republic and Aid flow from UN agencies (US$) in Somalia?
Provide a succinct answer. -1.48e+06. In the year 2005, what is the difference between the Aid flow from UN agencies (US$) in Europe(all income levels) and Aid flow from UN agencies (US$) in Low & middle income?
Give a very brief answer. -5.48e+08. In the year 2005, what is the difference between the Aid flow from UN agencies (US$) of Europe(all income levels) and Aid flow from UN agencies (US$) of Dominican Republic?
Your answer should be very brief. 6.54e+06. In the year 2005, what is the difference between the Aid flow from UN agencies (US$) of Europe(all income levels) and Aid flow from UN agencies (US$) of Somalia?
Provide a succinct answer. 1.35e+06. In the year 2005, what is the difference between the Aid flow from UN agencies (US$) in Low & middle income and Aid flow from UN agencies (US$) in Dominican Republic?
Ensure brevity in your answer.  5.54e+08. In the year 2005, what is the difference between the Aid flow from UN agencies (US$) of Low & middle income and Aid flow from UN agencies (US$) of Somalia?
Ensure brevity in your answer.  5.49e+08. In the year 2005, what is the difference between the Aid flow from UN agencies (US$) in Dominican Republic and Aid flow from UN agencies (US$) in Somalia?
Provide a short and direct response. -5.19e+06. In the year 2008, what is the difference between the Aid flow from UN agencies (US$) in Europe(all income levels) and Aid flow from UN agencies (US$) in Low & middle income?
Offer a very short reply. -3.05e+08. In the year 2008, what is the difference between the Aid flow from UN agencies (US$) in Europe(all income levels) and Aid flow from UN agencies (US$) in Dominican Republic?
Ensure brevity in your answer.  1.03e+07. In the year 2008, what is the difference between the Aid flow from UN agencies (US$) of Europe(all income levels) and Aid flow from UN agencies (US$) of Somalia?
Offer a terse response. 4.45e+06. In the year 2008, what is the difference between the Aid flow from UN agencies (US$) in Low & middle income and Aid flow from UN agencies (US$) in Dominican Republic?
Offer a terse response. 3.16e+08. In the year 2008, what is the difference between the Aid flow from UN agencies (US$) of Low & middle income and Aid flow from UN agencies (US$) of Somalia?
Offer a very short reply. 3.10e+08. In the year 2008, what is the difference between the Aid flow from UN agencies (US$) of Dominican Republic and Aid flow from UN agencies (US$) of Somalia?
Provide a succinct answer. -5.84e+06. In the year 2009, what is the difference between the Aid flow from UN agencies (US$) in Europe(all income levels) and Aid flow from UN agencies (US$) in Low & middle income?
Ensure brevity in your answer.  -2.86e+08. In the year 2009, what is the difference between the Aid flow from UN agencies (US$) of Europe(all income levels) and Aid flow from UN agencies (US$) of Dominican Republic?
Keep it short and to the point. 4.02e+06. In the year 2009, what is the difference between the Aid flow from UN agencies (US$) in Europe(all income levels) and Aid flow from UN agencies (US$) in Somalia?
Ensure brevity in your answer.  -1.06e+07. In the year 2009, what is the difference between the Aid flow from UN agencies (US$) of Low & middle income and Aid flow from UN agencies (US$) of Dominican Republic?
Provide a short and direct response. 2.90e+08. In the year 2009, what is the difference between the Aid flow from UN agencies (US$) in Low & middle income and Aid flow from UN agencies (US$) in Somalia?
Give a very brief answer. 2.76e+08. In the year 2009, what is the difference between the Aid flow from UN agencies (US$) of Dominican Republic and Aid flow from UN agencies (US$) of Somalia?
Keep it short and to the point. -1.46e+07. What is the ratio of the Aid flow from UN agencies (US$) in Europe(all income levels) in 2001 to that in 2002?
Give a very brief answer. 1.78. What is the ratio of the Aid flow from UN agencies (US$) in Low & middle income in 2001 to that in 2002?
Provide a short and direct response. 1.08. What is the ratio of the Aid flow from UN agencies (US$) of Dominican Republic in 2001 to that in 2002?
Your answer should be compact. 5.95. What is the ratio of the Aid flow from UN agencies (US$) in Somalia in 2001 to that in 2002?
Offer a very short reply. 0.71. What is the ratio of the Aid flow from UN agencies (US$) in Europe(all income levels) in 2001 to that in 2003?
Keep it short and to the point. 2.69. What is the ratio of the Aid flow from UN agencies (US$) of Low & middle income in 2001 to that in 2003?
Your response must be concise. 1.07. What is the ratio of the Aid flow from UN agencies (US$) of Dominican Republic in 2001 to that in 2003?
Offer a terse response. 5.14. What is the ratio of the Aid flow from UN agencies (US$) in Somalia in 2001 to that in 2003?
Give a very brief answer. 0.47. What is the ratio of the Aid flow from UN agencies (US$) of Europe(all income levels) in 2001 to that in 2004?
Your answer should be compact. 3.74. What is the ratio of the Aid flow from UN agencies (US$) in Low & middle income in 2001 to that in 2004?
Make the answer very short. 1.5. What is the ratio of the Aid flow from UN agencies (US$) of Dominican Republic in 2001 to that in 2004?
Keep it short and to the point. 13.29. What is the ratio of the Aid flow from UN agencies (US$) in Europe(all income levels) in 2001 to that in 2005?
Offer a very short reply. 3.09. What is the ratio of the Aid flow from UN agencies (US$) in Low & middle income in 2001 to that in 2005?
Provide a succinct answer. 0.68. What is the ratio of the Aid flow from UN agencies (US$) of Dominican Republic in 2001 to that in 2005?
Your response must be concise. 113. What is the ratio of the Aid flow from UN agencies (US$) of Somalia in 2001 to that in 2005?
Give a very brief answer. 0.19. What is the ratio of the Aid flow from UN agencies (US$) of Europe(all income levels) in 2001 to that in 2008?
Provide a short and direct response. 1.85. What is the ratio of the Aid flow from UN agencies (US$) of Low & middle income in 2001 to that in 2008?
Offer a terse response. 1.2. What is the ratio of the Aid flow from UN agencies (US$) of Dominican Republic in 2001 to that in 2008?
Provide a succinct answer. 3.28. What is the ratio of the Aid flow from UN agencies (US$) of Somalia in 2001 to that in 2008?
Make the answer very short. 0.15. What is the ratio of the Aid flow from UN agencies (US$) in Europe(all income levels) in 2001 to that in 2009?
Offer a terse response. 5.01. What is the ratio of the Aid flow from UN agencies (US$) of Low & middle income in 2001 to that in 2009?
Give a very brief answer. 1.31. What is the ratio of the Aid flow from UN agencies (US$) of Dominican Republic in 2001 to that in 2009?
Keep it short and to the point. 75.33. What is the ratio of the Aid flow from UN agencies (US$) of Somalia in 2001 to that in 2009?
Offer a terse response. 0.07. What is the ratio of the Aid flow from UN agencies (US$) of Europe(all income levels) in 2002 to that in 2003?
Offer a terse response. 1.51. What is the ratio of the Aid flow from UN agencies (US$) in Dominican Republic in 2002 to that in 2003?
Make the answer very short. 0.86. What is the ratio of the Aid flow from UN agencies (US$) in Somalia in 2002 to that in 2003?
Your answer should be very brief. 0.66. What is the ratio of the Aid flow from UN agencies (US$) in Europe(all income levels) in 2002 to that in 2004?
Your answer should be very brief. 2.1. What is the ratio of the Aid flow from UN agencies (US$) of Low & middle income in 2002 to that in 2004?
Your answer should be very brief. 1.39. What is the ratio of the Aid flow from UN agencies (US$) in Dominican Republic in 2002 to that in 2004?
Offer a very short reply. 2.24. What is the ratio of the Aid flow from UN agencies (US$) in Somalia in 2002 to that in 2004?
Your answer should be very brief. 0.84. What is the ratio of the Aid flow from UN agencies (US$) in Europe(all income levels) in 2002 to that in 2005?
Your response must be concise. 1.74. What is the ratio of the Aid flow from UN agencies (US$) of Low & middle income in 2002 to that in 2005?
Your answer should be very brief. 0.63. What is the ratio of the Aid flow from UN agencies (US$) of Dominican Republic in 2002 to that in 2005?
Your response must be concise. 19. What is the ratio of the Aid flow from UN agencies (US$) of Somalia in 2002 to that in 2005?
Give a very brief answer. 0.27. What is the ratio of the Aid flow from UN agencies (US$) in Europe(all income levels) in 2002 to that in 2008?
Your answer should be compact. 1.04. What is the ratio of the Aid flow from UN agencies (US$) of Low & middle income in 2002 to that in 2008?
Your answer should be compact. 1.11. What is the ratio of the Aid flow from UN agencies (US$) in Dominican Republic in 2002 to that in 2008?
Keep it short and to the point. 0.55. What is the ratio of the Aid flow from UN agencies (US$) of Somalia in 2002 to that in 2008?
Provide a short and direct response. 0.21. What is the ratio of the Aid flow from UN agencies (US$) of Europe(all income levels) in 2002 to that in 2009?
Offer a terse response. 2.81. What is the ratio of the Aid flow from UN agencies (US$) of Low & middle income in 2002 to that in 2009?
Keep it short and to the point. 1.21. What is the ratio of the Aid flow from UN agencies (US$) of Dominican Republic in 2002 to that in 2009?
Provide a succinct answer. 12.67. What is the ratio of the Aid flow from UN agencies (US$) in Somalia in 2002 to that in 2009?
Offer a very short reply. 0.09. What is the ratio of the Aid flow from UN agencies (US$) of Europe(all income levels) in 2003 to that in 2004?
Keep it short and to the point. 1.39. What is the ratio of the Aid flow from UN agencies (US$) of Low & middle income in 2003 to that in 2004?
Your answer should be compact. 1.4. What is the ratio of the Aid flow from UN agencies (US$) of Dominican Republic in 2003 to that in 2004?
Your response must be concise. 2.59. What is the ratio of the Aid flow from UN agencies (US$) of Somalia in 2003 to that in 2004?
Offer a very short reply. 1.28. What is the ratio of the Aid flow from UN agencies (US$) in Europe(all income levels) in 2003 to that in 2005?
Provide a succinct answer. 1.15. What is the ratio of the Aid flow from UN agencies (US$) in Low & middle income in 2003 to that in 2005?
Offer a terse response. 0.64. What is the ratio of the Aid flow from UN agencies (US$) of Dominican Republic in 2003 to that in 2005?
Provide a succinct answer. 22. What is the ratio of the Aid flow from UN agencies (US$) of Somalia in 2003 to that in 2005?
Your answer should be very brief. 0.41. What is the ratio of the Aid flow from UN agencies (US$) in Europe(all income levels) in 2003 to that in 2008?
Offer a very short reply. 0.69. What is the ratio of the Aid flow from UN agencies (US$) of Low & middle income in 2003 to that in 2008?
Offer a very short reply. 1.12. What is the ratio of the Aid flow from UN agencies (US$) of Dominican Republic in 2003 to that in 2008?
Your response must be concise. 0.64. What is the ratio of the Aid flow from UN agencies (US$) in Somalia in 2003 to that in 2008?
Your response must be concise. 0.32. What is the ratio of the Aid flow from UN agencies (US$) of Europe(all income levels) in 2003 to that in 2009?
Make the answer very short. 1.86. What is the ratio of the Aid flow from UN agencies (US$) in Low & middle income in 2003 to that in 2009?
Offer a terse response. 1.22. What is the ratio of the Aid flow from UN agencies (US$) of Dominican Republic in 2003 to that in 2009?
Make the answer very short. 14.67. What is the ratio of the Aid flow from UN agencies (US$) of Somalia in 2003 to that in 2009?
Your answer should be very brief. 0.14. What is the ratio of the Aid flow from UN agencies (US$) in Europe(all income levels) in 2004 to that in 2005?
Give a very brief answer. 0.83. What is the ratio of the Aid flow from UN agencies (US$) of Low & middle income in 2004 to that in 2005?
Your answer should be very brief. 0.46. What is the ratio of the Aid flow from UN agencies (US$) in Dominican Republic in 2004 to that in 2005?
Provide a succinct answer. 8.5. What is the ratio of the Aid flow from UN agencies (US$) in Somalia in 2004 to that in 2005?
Your answer should be compact. 0.32. What is the ratio of the Aid flow from UN agencies (US$) in Europe(all income levels) in 2004 to that in 2008?
Your response must be concise. 0.49. What is the ratio of the Aid flow from UN agencies (US$) in Low & middle income in 2004 to that in 2008?
Make the answer very short. 0.8. What is the ratio of the Aid flow from UN agencies (US$) of Dominican Republic in 2004 to that in 2008?
Offer a very short reply. 0.25. What is the ratio of the Aid flow from UN agencies (US$) of Somalia in 2004 to that in 2008?
Your response must be concise. 0.25. What is the ratio of the Aid flow from UN agencies (US$) in Europe(all income levels) in 2004 to that in 2009?
Offer a terse response. 1.34. What is the ratio of the Aid flow from UN agencies (US$) of Low & middle income in 2004 to that in 2009?
Give a very brief answer. 0.87. What is the ratio of the Aid flow from UN agencies (US$) in Dominican Republic in 2004 to that in 2009?
Offer a very short reply. 5.67. What is the ratio of the Aid flow from UN agencies (US$) of Somalia in 2004 to that in 2009?
Ensure brevity in your answer.  0.11. What is the ratio of the Aid flow from UN agencies (US$) in Europe(all income levels) in 2005 to that in 2008?
Your answer should be very brief. 0.6. What is the ratio of the Aid flow from UN agencies (US$) of Low & middle income in 2005 to that in 2008?
Provide a short and direct response. 1.75. What is the ratio of the Aid flow from UN agencies (US$) of Dominican Republic in 2005 to that in 2008?
Provide a succinct answer. 0.03. What is the ratio of the Aid flow from UN agencies (US$) in Somalia in 2005 to that in 2008?
Ensure brevity in your answer.  0.8. What is the ratio of the Aid flow from UN agencies (US$) in Europe(all income levels) in 2005 to that in 2009?
Your answer should be compact. 1.62. What is the ratio of the Aid flow from UN agencies (US$) in Low & middle income in 2005 to that in 2009?
Give a very brief answer. 1.91. What is the ratio of the Aid flow from UN agencies (US$) of Somalia in 2005 to that in 2009?
Provide a succinct answer. 0.36. What is the ratio of the Aid flow from UN agencies (US$) of Europe(all income levels) in 2008 to that in 2009?
Keep it short and to the point. 2.71. What is the ratio of the Aid flow from UN agencies (US$) in Low & middle income in 2008 to that in 2009?
Provide a succinct answer. 1.09. What is the ratio of the Aid flow from UN agencies (US$) in Somalia in 2008 to that in 2009?
Offer a terse response. 0.45. What is the difference between the highest and the second highest Aid flow from UN agencies (US$) of Europe(all income levels)?
Offer a terse response. 8.89e+06. What is the difference between the highest and the second highest Aid flow from UN agencies (US$) of Low & middle income?
Provide a succinct answer. 1.75e+08. What is the difference between the highest and the second highest Aid flow from UN agencies (US$) in Dominican Republic?
Offer a terse response. 1.57e+06. What is the difference between the highest and the second highest Aid flow from UN agencies (US$) of Somalia?
Keep it short and to the point. 8.11e+06. What is the difference between the highest and the lowest Aid flow from UN agencies (US$) of Europe(all income levels)?
Provide a succinct answer. 1.62e+07. What is the difference between the highest and the lowest Aid flow from UN agencies (US$) of Low & middle income?
Your response must be concise. 3.02e+08. What is the difference between the highest and the lowest Aid flow from UN agencies (US$) of Dominican Republic?
Your response must be concise. 2.24e+06. What is the difference between the highest and the lowest Aid flow from UN agencies (US$) in Somalia?
Your answer should be compact. 1.36e+07. 